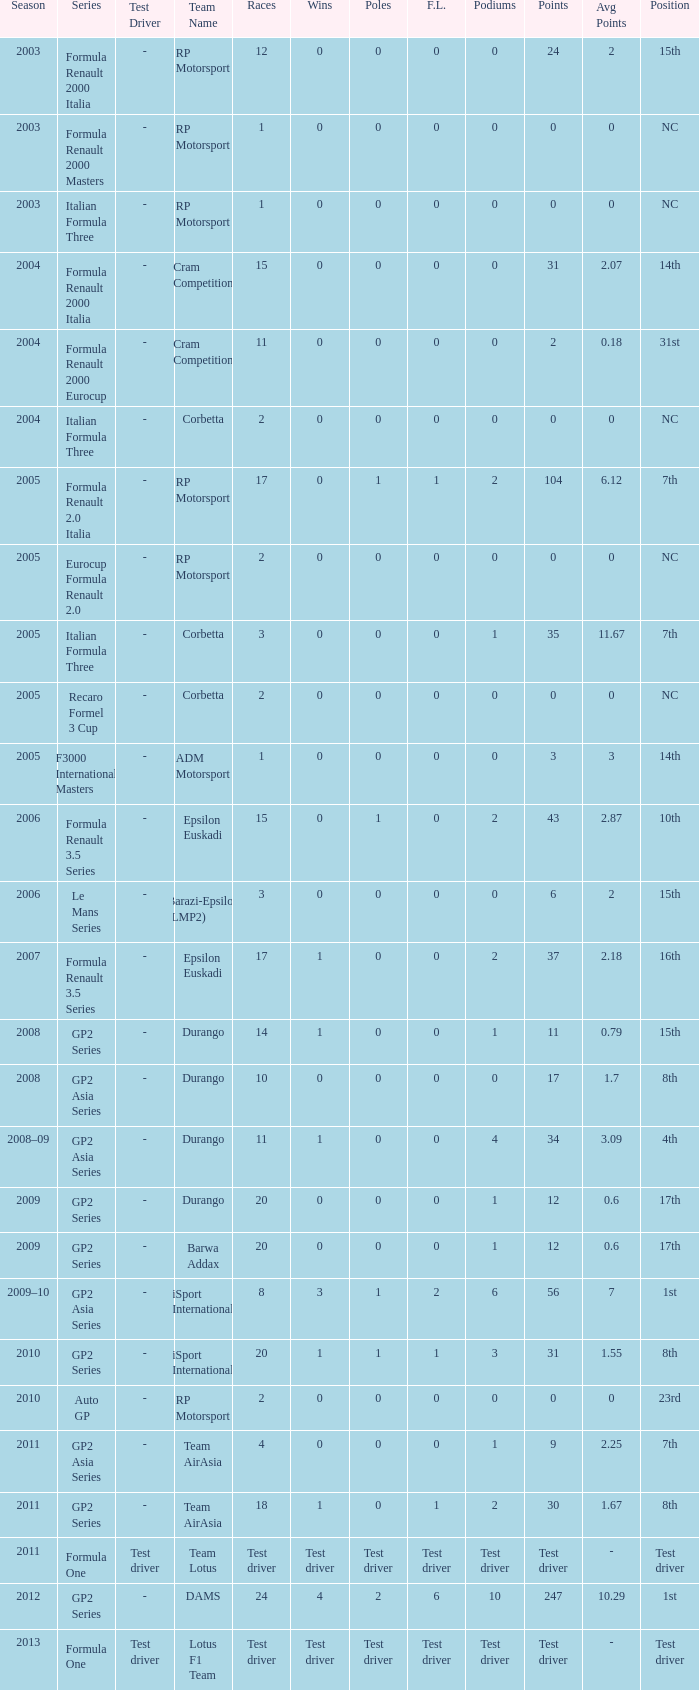What is the number of poles with 104 points? 1.0. 